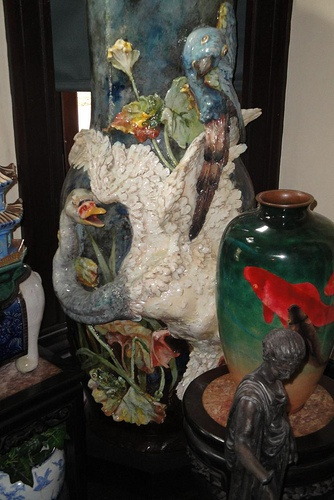Describe the objects in this image and their specific colors. I can see a vase in gray, black, darkgreen, maroon, and brown tones in this image. 